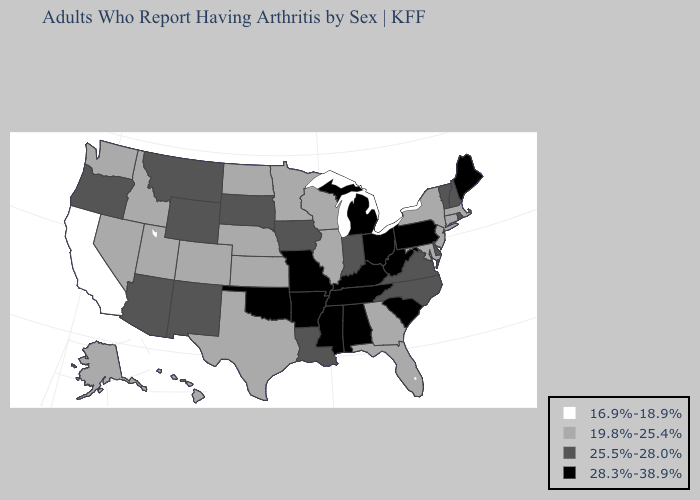Name the states that have a value in the range 19.8%-25.4%?
Give a very brief answer. Alaska, Colorado, Connecticut, Florida, Georgia, Hawaii, Idaho, Illinois, Kansas, Maryland, Massachusetts, Minnesota, Nebraska, Nevada, New Jersey, New York, North Dakota, Texas, Utah, Washington, Wisconsin. What is the lowest value in the Northeast?
Concise answer only. 19.8%-25.4%. Among the states that border Idaho , which have the highest value?
Give a very brief answer. Montana, Oregon, Wyoming. Does Oregon have a higher value than Michigan?
Write a very short answer. No. What is the value of Pennsylvania?
Answer briefly. 28.3%-38.9%. What is the value of Minnesota?
Keep it brief. 19.8%-25.4%. How many symbols are there in the legend?
Keep it brief. 4. What is the lowest value in the South?
Quick response, please. 19.8%-25.4%. Does Oregon have the same value as South Carolina?
Answer briefly. No. Name the states that have a value in the range 19.8%-25.4%?
Concise answer only. Alaska, Colorado, Connecticut, Florida, Georgia, Hawaii, Idaho, Illinois, Kansas, Maryland, Massachusetts, Minnesota, Nebraska, Nevada, New Jersey, New York, North Dakota, Texas, Utah, Washington, Wisconsin. Does Wyoming have the highest value in the West?
Write a very short answer. Yes. What is the value of Montana?
Give a very brief answer. 25.5%-28.0%. Among the states that border Tennessee , which have the lowest value?
Give a very brief answer. Georgia. What is the value of Missouri?
Be succinct. 28.3%-38.9%. What is the value of Hawaii?
Be succinct. 19.8%-25.4%. 